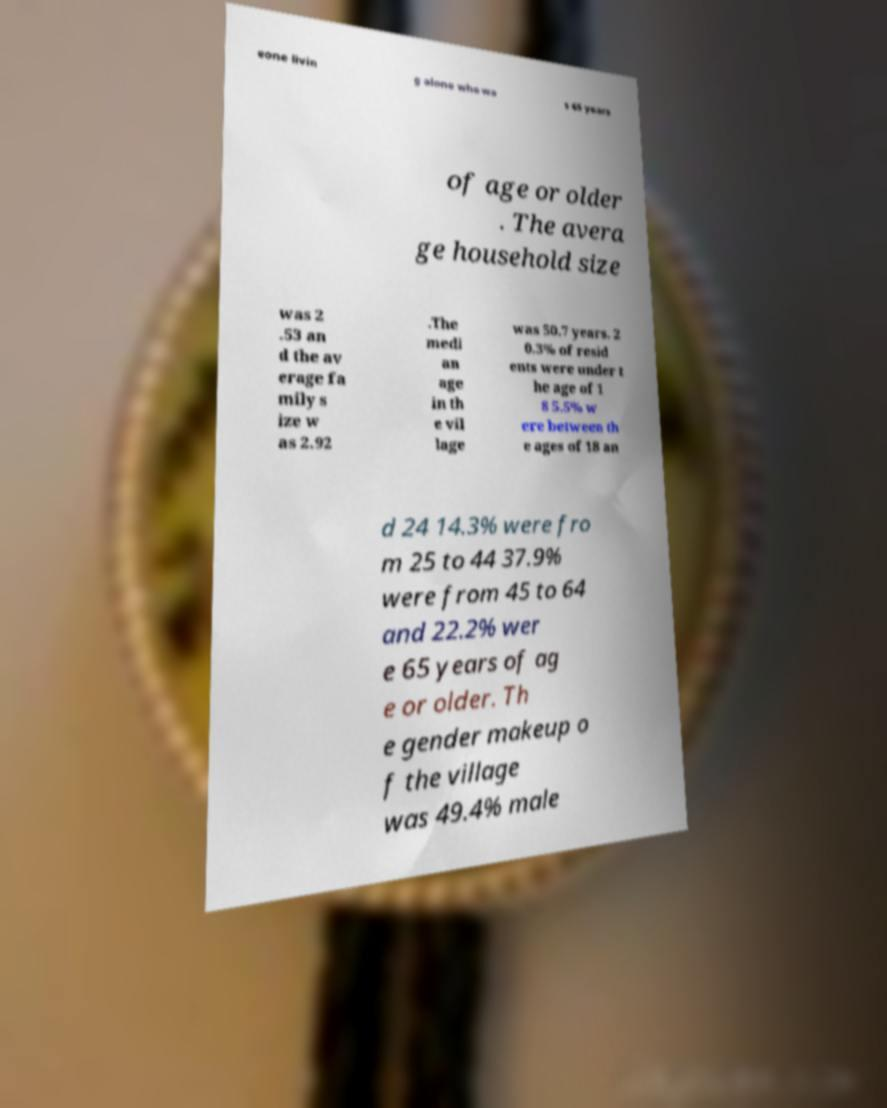Can you accurately transcribe the text from the provided image for me? eone livin g alone who wa s 65 years of age or older . The avera ge household size was 2 .53 an d the av erage fa mily s ize w as 2.92 .The medi an age in th e vil lage was 50.7 years. 2 0.3% of resid ents were under t he age of 1 8 5.5% w ere between th e ages of 18 an d 24 14.3% were fro m 25 to 44 37.9% were from 45 to 64 and 22.2% wer e 65 years of ag e or older. Th e gender makeup o f the village was 49.4% male 